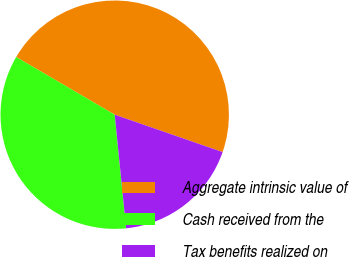<chart> <loc_0><loc_0><loc_500><loc_500><pie_chart><fcel>Aggregate intrinsic value of<fcel>Cash received from the<fcel>Tax benefits realized on<nl><fcel>46.88%<fcel>35.02%<fcel>18.1%<nl></chart> 